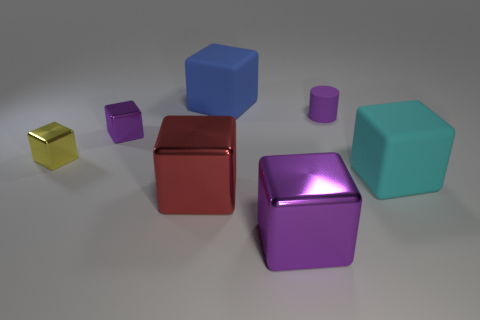Subtract all big cyan cubes. How many cubes are left? 5 Subtract all blue blocks. How many blocks are left? 5 Add 3 small blocks. How many objects exist? 10 Subtract 2 blocks. How many blocks are left? 4 Subtract all cylinders. How many objects are left? 6 Add 7 small yellow metal things. How many small yellow metal things exist? 8 Subtract 0 gray cylinders. How many objects are left? 7 Subtract all cyan blocks. Subtract all gray balls. How many blocks are left? 5 Subtract all cyan spheres. How many yellow cylinders are left? 0 Subtract all large gray rubber things. Subtract all large blue rubber cubes. How many objects are left? 6 